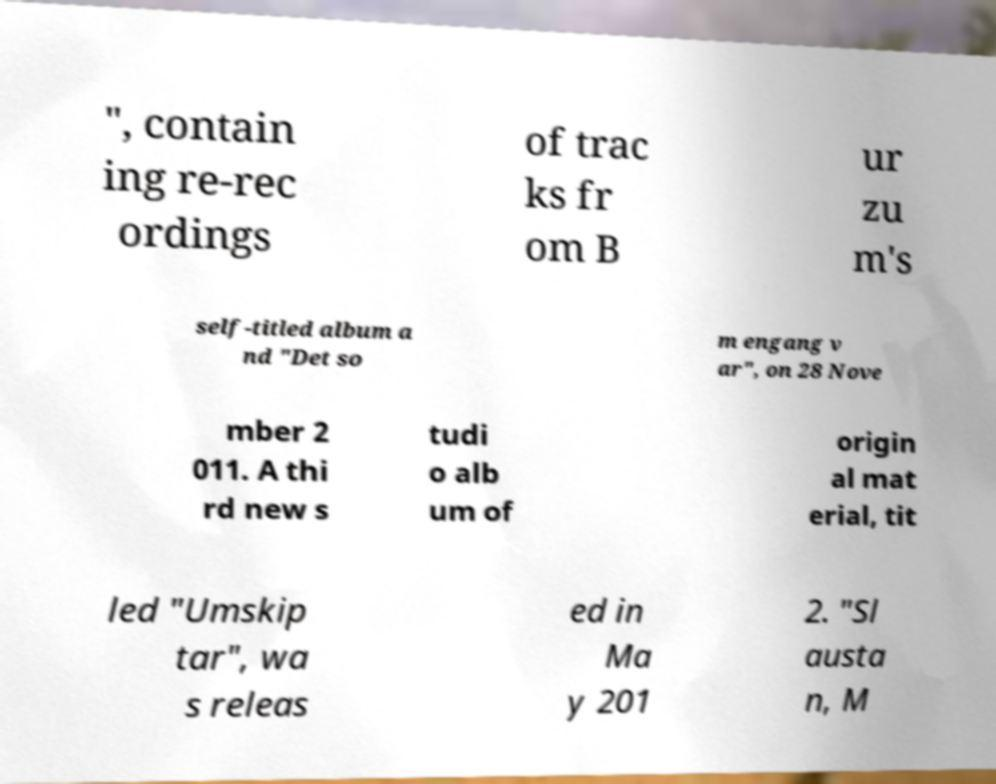Could you extract and type out the text from this image? ", contain ing re-rec ordings of trac ks fr om B ur zu m's self-titled album a nd "Det so m engang v ar", on 28 Nove mber 2 011. A thi rd new s tudi o alb um of origin al mat erial, tit led "Umskip tar", wa s releas ed in Ma y 201 2. "Sl austa n, M 